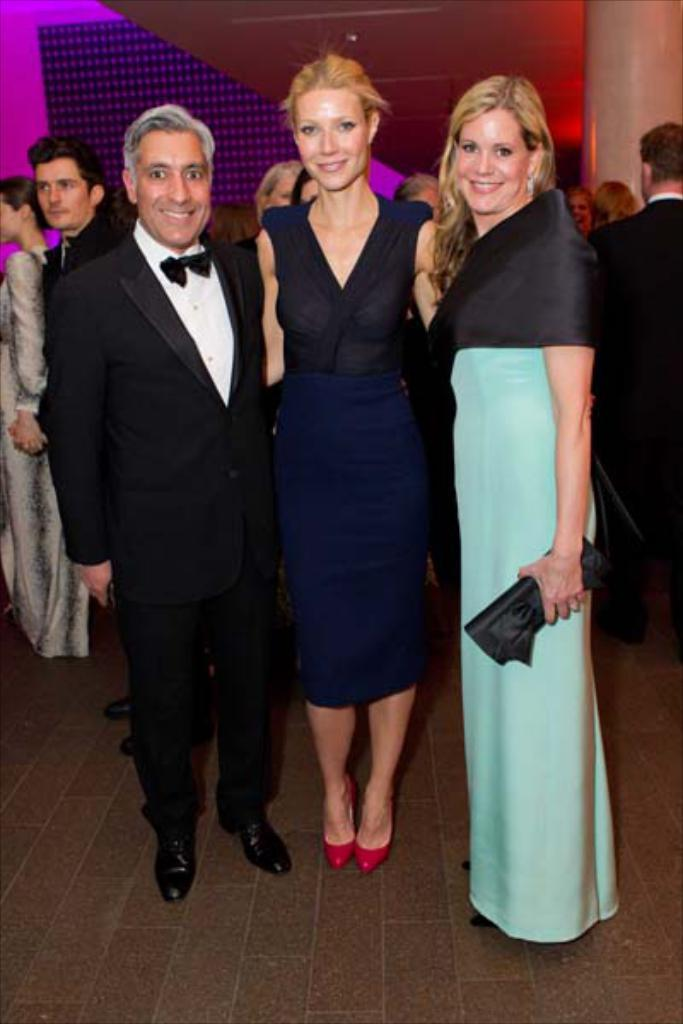What can be seen in the image in terms of human presence? There are people standing in the image. What architectural feature is present in the image? There is a pillar in the image. What other structural element can be seen in the image? There is a wall in the image. What type of lock is used to secure the pillar in the image? There is no lock present in the image, nor is there any indication that the pillar needs to be secured. What is the chemical composition of the wall in the image? The chemical composition of the wall is not mentioned or visible in the image. 